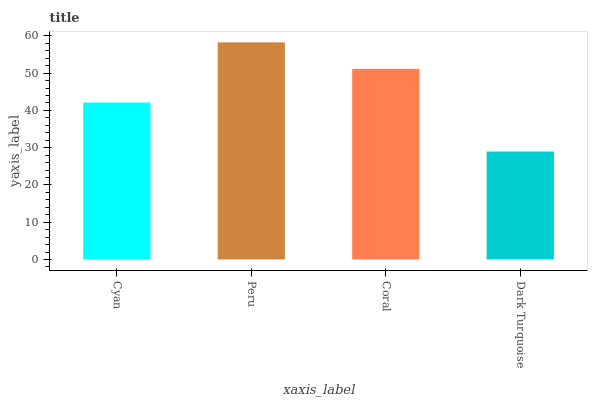Is Dark Turquoise the minimum?
Answer yes or no. Yes. Is Peru the maximum?
Answer yes or no. Yes. Is Coral the minimum?
Answer yes or no. No. Is Coral the maximum?
Answer yes or no. No. Is Peru greater than Coral?
Answer yes or no. Yes. Is Coral less than Peru?
Answer yes or no. Yes. Is Coral greater than Peru?
Answer yes or no. No. Is Peru less than Coral?
Answer yes or no. No. Is Coral the high median?
Answer yes or no. Yes. Is Cyan the low median?
Answer yes or no. Yes. Is Peru the high median?
Answer yes or no. No. Is Coral the low median?
Answer yes or no. No. 